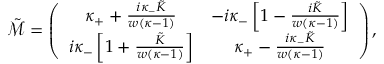<formula> <loc_0><loc_0><loc_500><loc_500>\tilde { \mathcal { M } } = \left ( \begin{array} { c c } { \kappa _ { + } + \frac { i \kappa _ { - } \tilde { K } } { w ( \kappa - 1 ) } } & { - i \kappa _ { - } \left [ 1 - \frac { i \tilde { K } } { w ( \kappa - 1 ) } \right ] } \\ { i \kappa _ { - } \left [ 1 + \frac { \tilde { K } } { w ( \kappa - 1 ) } \right ] } & { \kappa _ { + } - \frac { i \kappa _ { - } \tilde { K } } { w ( \kappa - 1 ) } } \end{array} \right ) ,</formula> 